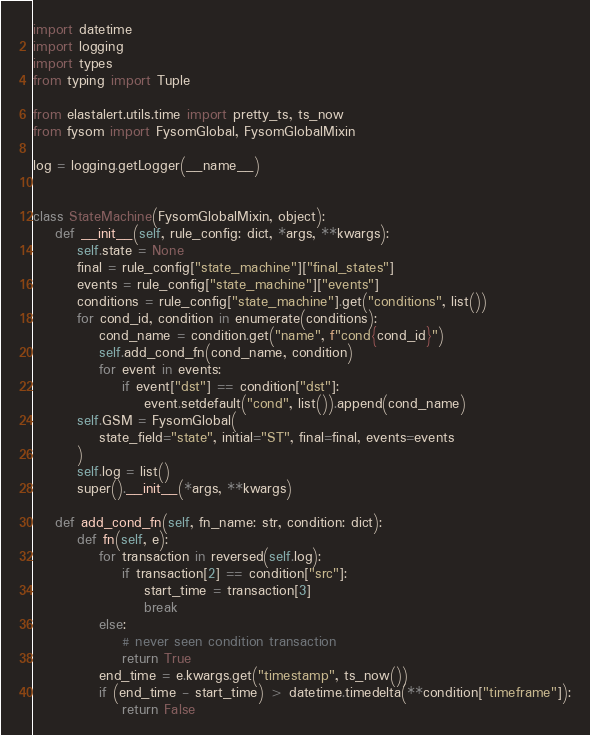Convert code to text. <code><loc_0><loc_0><loc_500><loc_500><_Python_>import datetime
import logging
import types
from typing import Tuple

from elastalert.utils.time import pretty_ts, ts_now
from fysom import FysomGlobal, FysomGlobalMixin

log = logging.getLogger(__name__)


class StateMachine(FysomGlobalMixin, object):
    def __init__(self, rule_config: dict, *args, **kwargs):
        self.state = None
        final = rule_config["state_machine"]["final_states"]
        events = rule_config["state_machine"]["events"]
        conditions = rule_config["state_machine"].get("conditions", list())
        for cond_id, condition in enumerate(conditions):
            cond_name = condition.get("name", f"cond{cond_id}")
            self.add_cond_fn(cond_name, condition)
            for event in events:
                if event["dst"] == condition["dst"]:
                    event.setdefault("cond", list()).append(cond_name)
        self.GSM = FysomGlobal(
            state_field="state", initial="ST", final=final, events=events
        )
        self.log = list()
        super().__init__(*args, **kwargs)

    def add_cond_fn(self, fn_name: str, condition: dict):
        def fn(self, e):
            for transaction in reversed(self.log):
                if transaction[2] == condition["src"]:
                    start_time = transaction[3]
                    break
            else:
                # never seen condition transaction
                return True
            end_time = e.kwargs.get("timestamp", ts_now())
            if (end_time - start_time) > datetime.timedelta(**condition["timeframe"]):
                return False</code> 